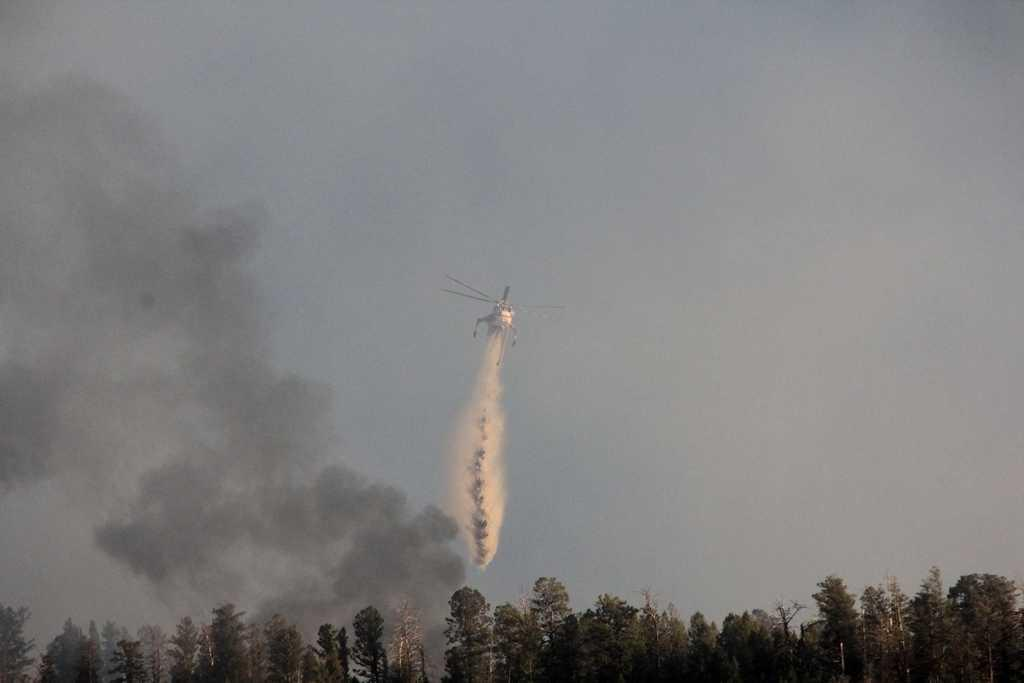What is flying in the sky in the image? There is a helicopter flying in the sky in the image. What can be seen in the air besides the helicopter? There is smoke in the air. What type of vegetation is visible in the image? There are many trees visible in the image. How would you describe the sky in the image? The sky is clear in the image. What type of steel is being used to aid the helicopter's digestion in the image? There is no steel or digestion mentioned in the image; it features a helicopter flying in the sky with smoke, trees, and a clear sky. 